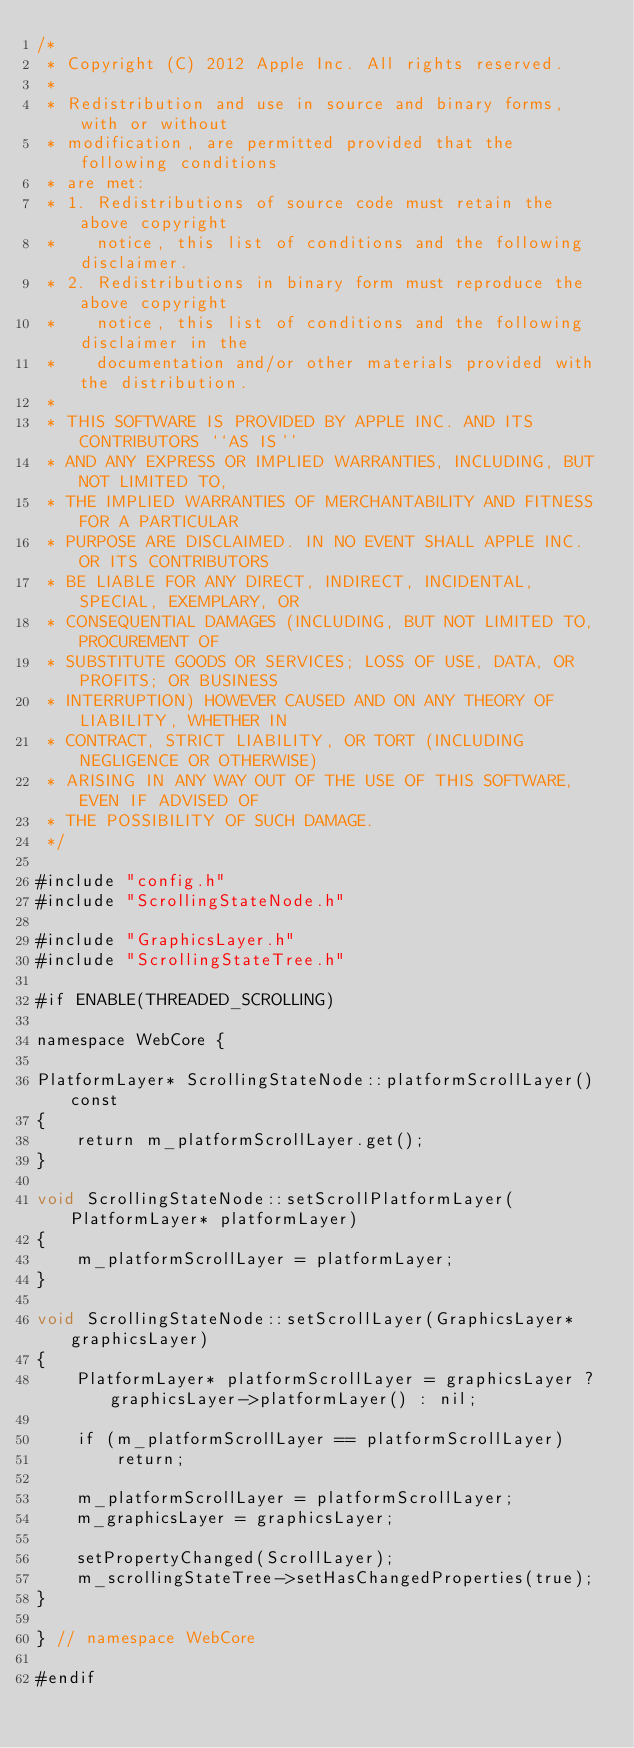Convert code to text. <code><loc_0><loc_0><loc_500><loc_500><_ObjectiveC_>/*
 * Copyright (C) 2012 Apple Inc. All rights reserved.
 *
 * Redistribution and use in source and binary forms, with or without
 * modification, are permitted provided that the following conditions
 * are met:
 * 1. Redistributions of source code must retain the above copyright
 *    notice, this list of conditions and the following disclaimer.
 * 2. Redistributions in binary form must reproduce the above copyright
 *    notice, this list of conditions and the following disclaimer in the
 *    documentation and/or other materials provided with the distribution.
 *
 * THIS SOFTWARE IS PROVIDED BY APPLE INC. AND ITS CONTRIBUTORS ``AS IS''
 * AND ANY EXPRESS OR IMPLIED WARRANTIES, INCLUDING, BUT NOT LIMITED TO,
 * THE IMPLIED WARRANTIES OF MERCHANTABILITY AND FITNESS FOR A PARTICULAR
 * PURPOSE ARE DISCLAIMED. IN NO EVENT SHALL APPLE INC. OR ITS CONTRIBUTORS
 * BE LIABLE FOR ANY DIRECT, INDIRECT, INCIDENTAL, SPECIAL, EXEMPLARY, OR
 * CONSEQUENTIAL DAMAGES (INCLUDING, BUT NOT LIMITED TO, PROCUREMENT OF
 * SUBSTITUTE GOODS OR SERVICES; LOSS OF USE, DATA, OR PROFITS; OR BUSINESS
 * INTERRUPTION) HOWEVER CAUSED AND ON ANY THEORY OF LIABILITY, WHETHER IN
 * CONTRACT, STRICT LIABILITY, OR TORT (INCLUDING NEGLIGENCE OR OTHERWISE)
 * ARISING IN ANY WAY OUT OF THE USE OF THIS SOFTWARE, EVEN IF ADVISED OF
 * THE POSSIBILITY OF SUCH DAMAGE.
 */

#include "config.h"
#include "ScrollingStateNode.h"

#include "GraphicsLayer.h"
#include "ScrollingStateTree.h"

#if ENABLE(THREADED_SCROLLING)

namespace WebCore {

PlatformLayer* ScrollingStateNode::platformScrollLayer() const
{
    return m_platformScrollLayer.get();
}

void ScrollingStateNode::setScrollPlatformLayer(PlatformLayer* platformLayer)
{
    m_platformScrollLayer = platformLayer;
}

void ScrollingStateNode::setScrollLayer(GraphicsLayer* graphicsLayer)
{
    PlatformLayer* platformScrollLayer = graphicsLayer ? graphicsLayer->platformLayer() : nil;

    if (m_platformScrollLayer == platformScrollLayer)
        return;

    m_platformScrollLayer = platformScrollLayer;
    m_graphicsLayer = graphicsLayer;

    setPropertyChanged(ScrollLayer);
    m_scrollingStateTree->setHasChangedProperties(true);
}

} // namespace WebCore

#endif
</code> 